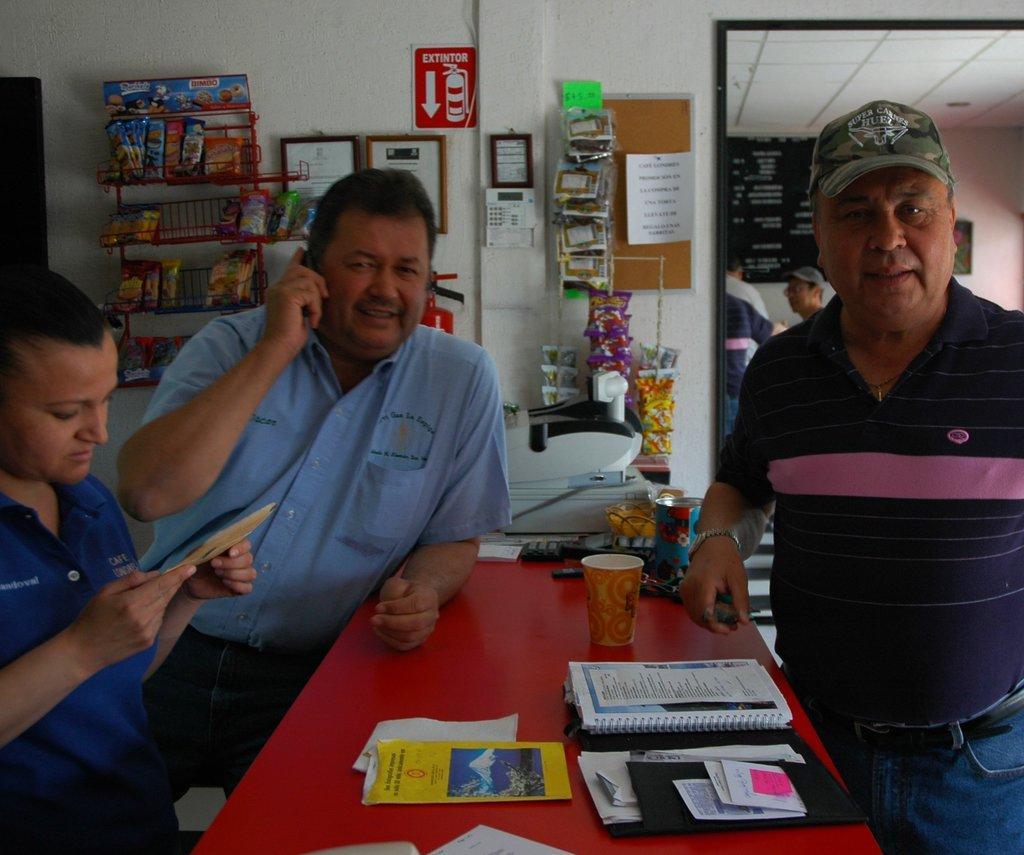Could you give a brief overview of what you see in this image? Here we can see people. This person is holding a paper. On this table there is a cup, books, papers and things. In this race there are food packets. Boards and pictures are on the wall. On this board there is a paper and things. Far there is a blackboard. Something written on this black board. In-front of this chalkboard there are people. 